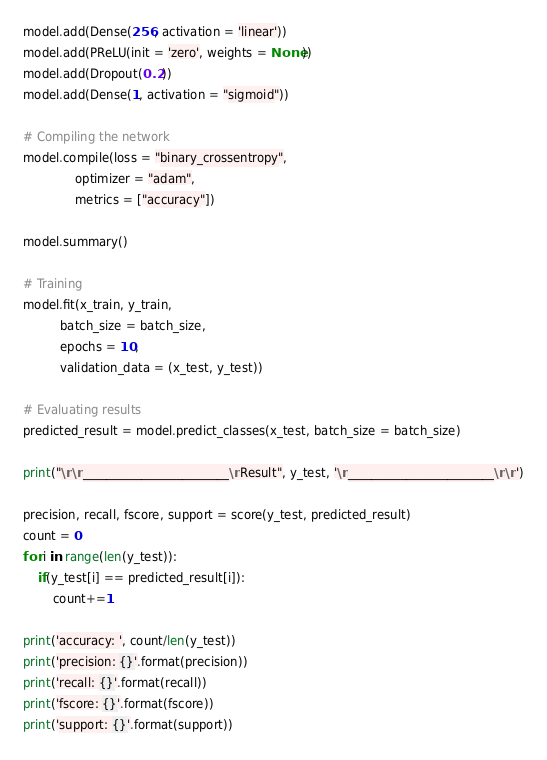<code> <loc_0><loc_0><loc_500><loc_500><_Python_>model.add(Dense(256, activation = 'linear'))
model.add(PReLU(init = 'zero', weights = None))
model.add(Dropout(0.2))
model.add(Dense(1, activation = "sigmoid"))

# Compiling the network
model.compile(loss = "binary_crossentropy",
              optimizer = "adam",
              metrics = ["accuracy"])

model.summary()

# Training
model.fit(x_train, y_train, 
          batch_size = batch_size, 
          epochs = 10,
          validation_data = (x_test, y_test))

# Evaluating results
predicted_result = model.predict_classes(x_test, batch_size = batch_size)

print("\n\n_________________________\nResult", y_test, '\n_________________________\n\n')
    
precision, recall, fscore, support = score(y_test, predicted_result)
count = 0
for i in range(len(y_test)):
    if(y_test[i] == predicted_result[i]):
        count+=1

print('accuracy: ', count/len(y_test))
print('precision: {}'.format(precision))
print('recall: {}'.format(recall))
print('fscore: {}'.format(fscore))
print('support: {}'.format(support))

</code> 